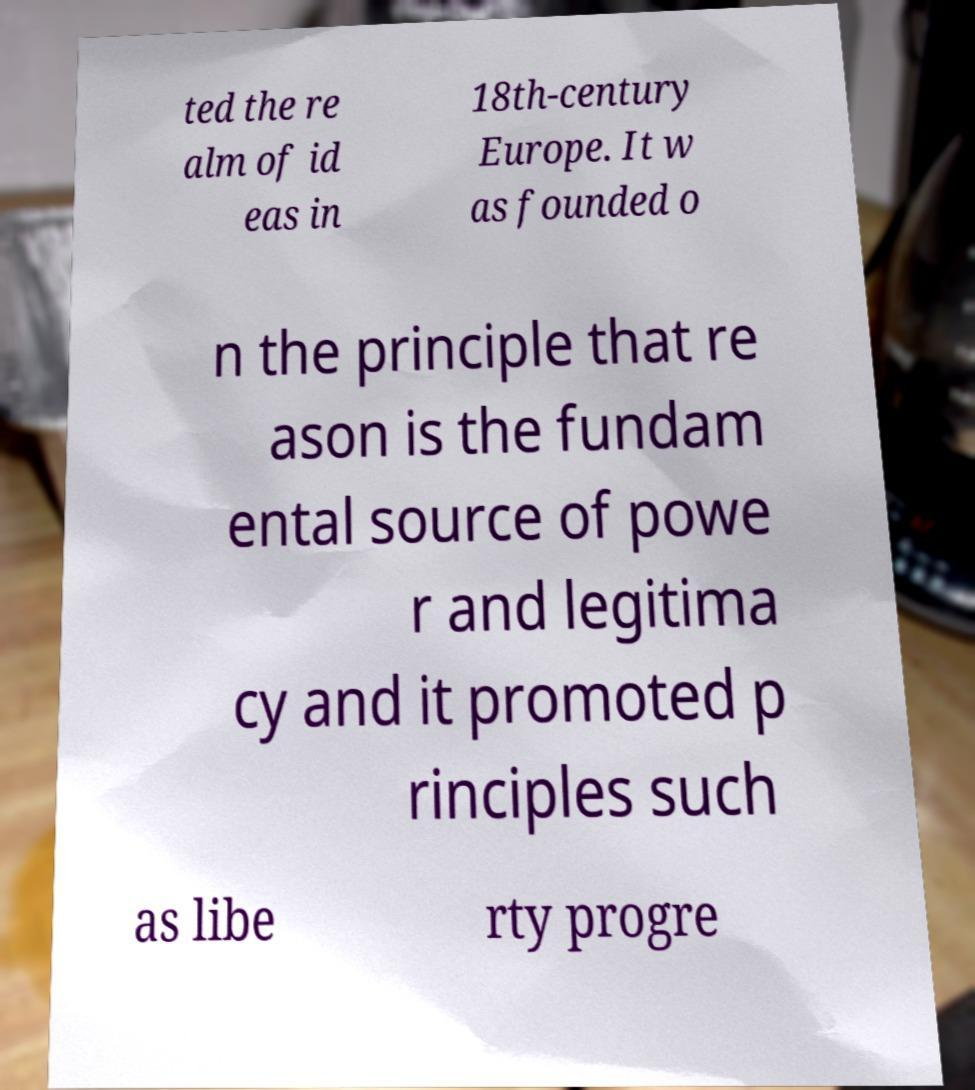What messages or text are displayed in this image? I need them in a readable, typed format. ted the re alm of id eas in 18th-century Europe. It w as founded o n the principle that re ason is the fundam ental source of powe r and legitima cy and it promoted p rinciples such as libe rty progre 